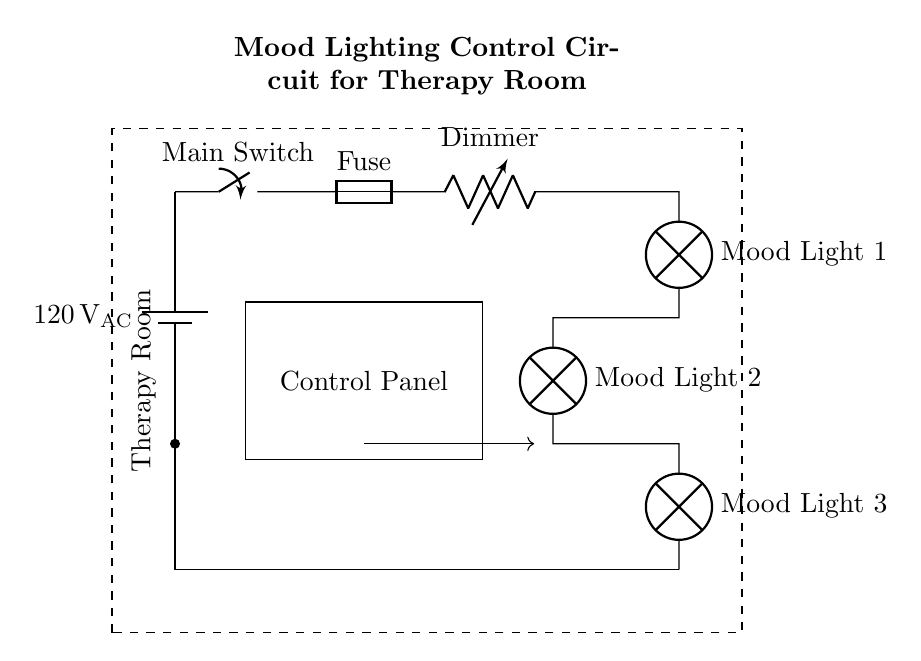What is the main voltage supply in this circuit? The main voltage supply is indicated on the battery symbol, showing it provides 120 volts of alternating current.
Answer: 120 volts AC What component adjusts the brightness of the mood lights? The circuit includes a component labeled as "Dimmer," which is a variable resistor used to change the resistance and consequently adjust the brightness of the connected lights.
Answer: Dimmer How many mood lights are present in the circuit? The circuit diagram shows three mood lights connected in parallel, which can be counted visually on the right side of the diagram.
Answer: Three What is the purpose of the fuse in the circuit? The fuse acts as a safety device that protects the circuit by breaking the connection if the current exceeds a certain value, preventing potential damage to the circuit components.
Answer: Safety If the main switch is turned off, what state are the mood lights in? When the main switch is turned off, it interrupts the current flow throughout the circuit, meaning that none of the mood lights will be illuminated regardless of the dimmer setting.
Answer: Off What type of configuration is used for the mood lights in this circuit? The mood lights are connected in parallel, which allows each light to operate independently and helps distribute the total current among them.
Answer: Parallel How does the control panel interact with the lighting circuit? The control panel is represented as a separate rectangle in the circuit, likely providing a means for the user to control the dimmer and turn the lights on or off, indicating a user-friendly interface for lighting management.
Answer: User interface 